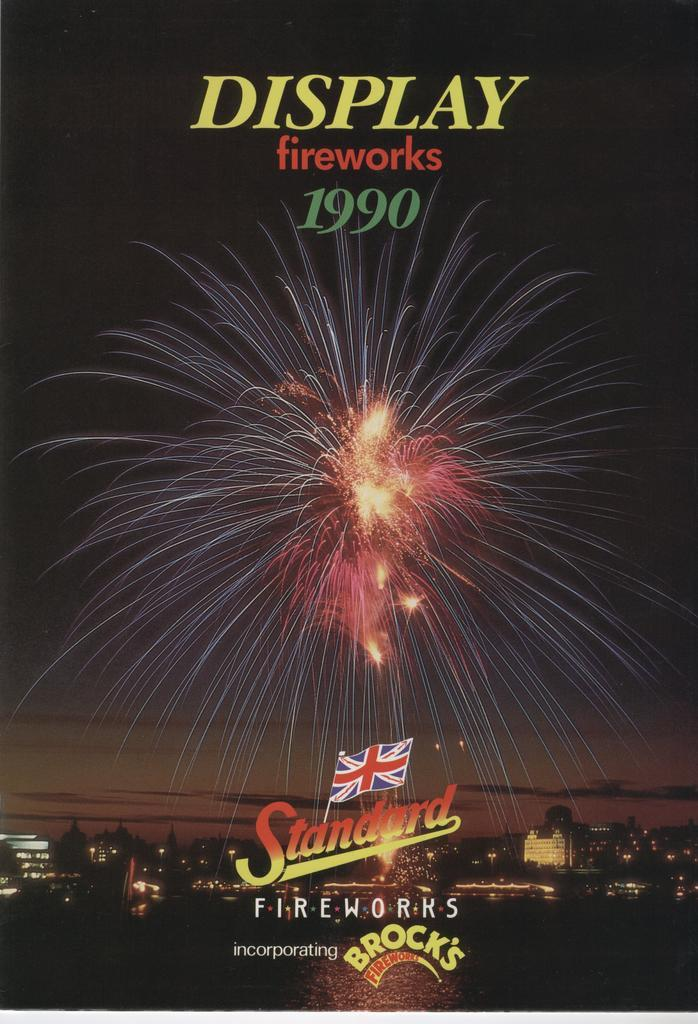<image>
Relay a brief, clear account of the picture shown. A poster advertises a fireworks show that took place in 1990. 